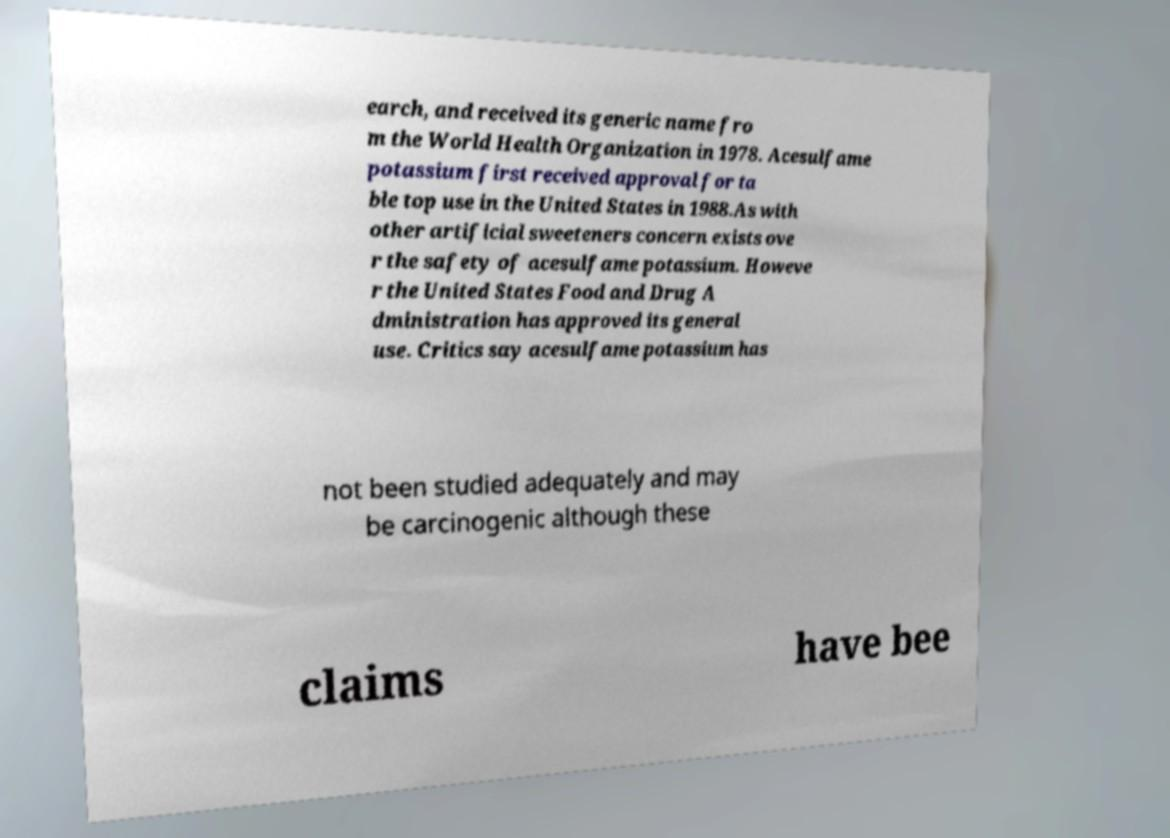Could you assist in decoding the text presented in this image and type it out clearly? earch, and received its generic name fro m the World Health Organization in 1978. Acesulfame potassium first received approval for ta ble top use in the United States in 1988.As with other artificial sweeteners concern exists ove r the safety of acesulfame potassium. Howeve r the United States Food and Drug A dministration has approved its general use. Critics say acesulfame potassium has not been studied adequately and may be carcinogenic although these claims have bee 